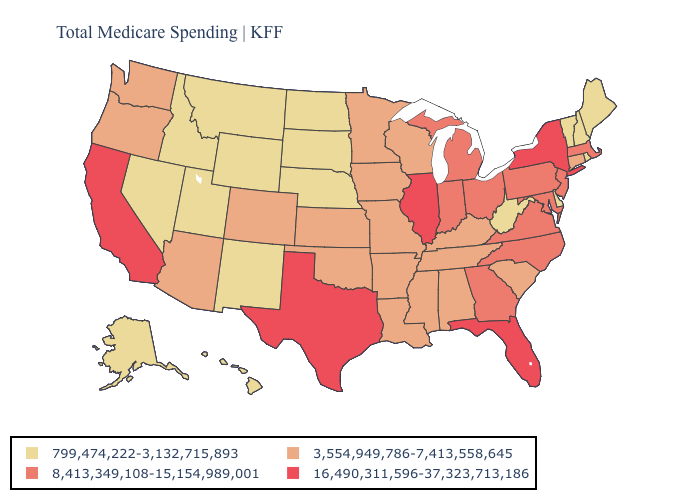Among the states that border Arkansas , which have the highest value?
Write a very short answer. Texas. Name the states that have a value in the range 3,554,949,786-7,413,558,645?
Write a very short answer. Alabama, Arizona, Arkansas, Colorado, Connecticut, Iowa, Kansas, Kentucky, Louisiana, Minnesota, Mississippi, Missouri, Oklahoma, Oregon, South Carolina, Tennessee, Washington, Wisconsin. What is the lowest value in the MidWest?
Keep it brief. 799,474,222-3,132,715,893. Name the states that have a value in the range 16,490,311,596-37,323,713,186?
Keep it brief. California, Florida, Illinois, New York, Texas. What is the value of Connecticut?
Answer briefly. 3,554,949,786-7,413,558,645. What is the highest value in states that border Oklahoma?
Quick response, please. 16,490,311,596-37,323,713,186. What is the highest value in the USA?
Quick response, please. 16,490,311,596-37,323,713,186. What is the lowest value in the USA?
Keep it brief. 799,474,222-3,132,715,893. Does California have the highest value in the West?
Short answer required. Yes. What is the highest value in the USA?
Short answer required. 16,490,311,596-37,323,713,186. Does Arkansas have the same value as Virginia?
Quick response, please. No. Does New York have the highest value in the USA?
Give a very brief answer. Yes. Does the first symbol in the legend represent the smallest category?
Answer briefly. Yes. What is the lowest value in the Northeast?
Write a very short answer. 799,474,222-3,132,715,893. What is the value of Texas?
Keep it brief. 16,490,311,596-37,323,713,186. 